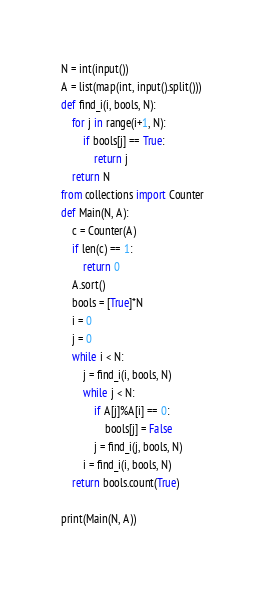Convert code to text. <code><loc_0><loc_0><loc_500><loc_500><_Python_>N = int(input())
A = list(map(int, input().split()))
def find_i(i, bools, N):
    for j in range(i+1, N):
        if bools[j] == True:
            return j
    return N
from collections import Counter
def Main(N, A):
    c = Counter(A)
    if len(c) == 1:
        return 0
    A.sort()
    bools = [True]*N
    i = 0
    j = 0
    while i < N:
        j = find_i(i, bools, N)
        while j < N:
            if A[j]%A[i] == 0:
                bools[j] = False
            j = find_i(j, bools, N)
        i = find_i(i, bools, N)
    return bools.count(True)

print(Main(N, A))</code> 